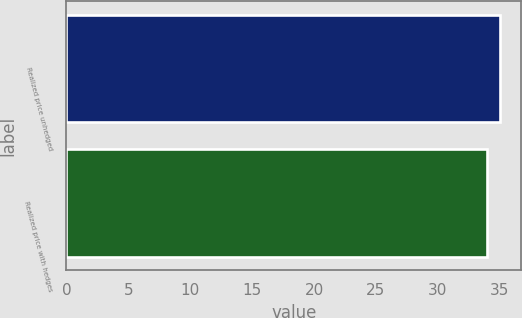Convert chart to OTSL. <chart><loc_0><loc_0><loc_500><loc_500><bar_chart><fcel>Realized price unhedged<fcel>Realized price with hedges<nl><fcel>35<fcel>34<nl></chart> 